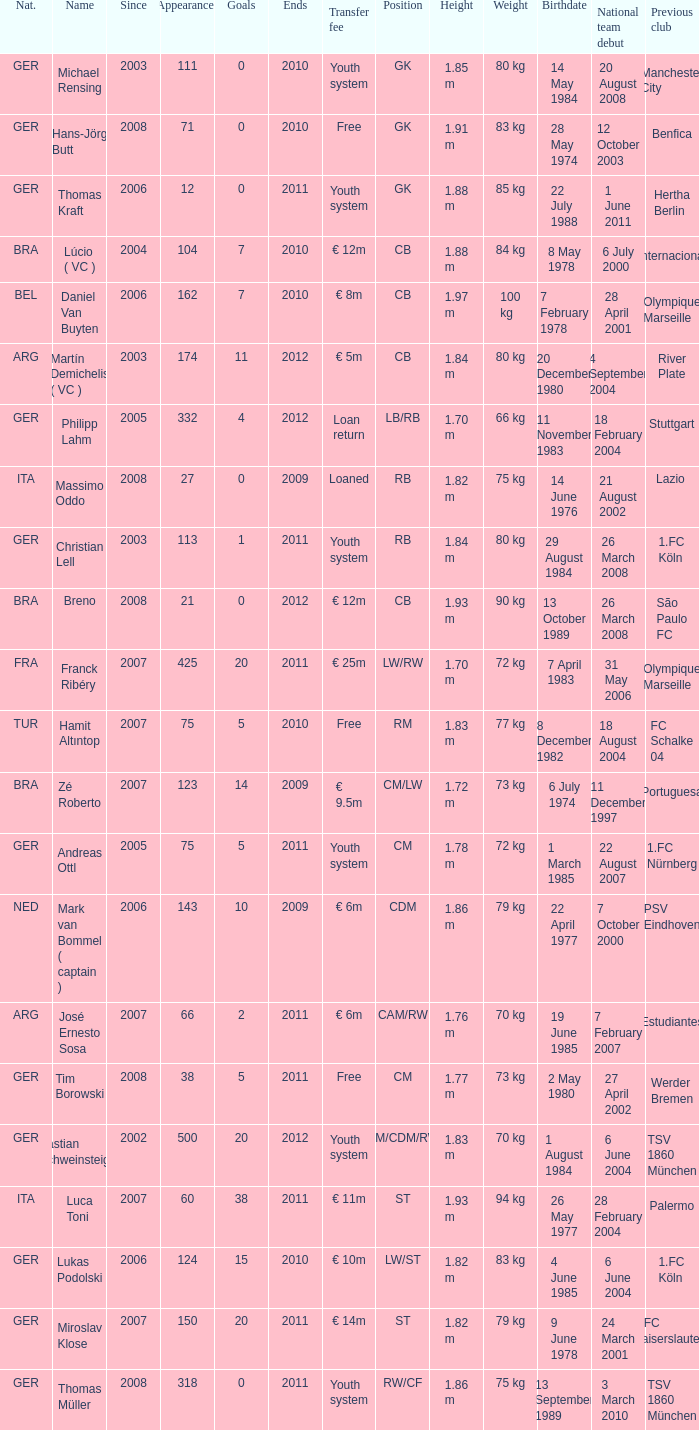What is the total number of ends after 2006 with a nationality of ita and 0 goals? 0.0. Give me the full table as a dictionary. {'header': ['Nat.', 'Name', 'Since', 'Appearances', 'Goals', 'Ends', 'Transfer fee', 'Position', 'Height', 'Weight', 'Birthdate', 'National team debut', 'Previous club '], 'rows': [['GER', 'Michael Rensing', '2003', '111', '0', '2010', 'Youth system', 'GK', '1.85 m', '80 kg', '14 May 1984', '20 August 2008', 'Manchester City '], ['GER', 'Hans-Jörg Butt', '2008', '71', '0', '2010', 'Free', 'GK', '1.91 m', '83 kg', '28 May 1974', '12 October 2003', 'Benfica '], ['GER', 'Thomas Kraft', '2006', '12', '0', '2011', 'Youth system', 'GK', '1.88 m', '85 kg', '22 July 1988', '1 June 2011', 'Hertha Berlin '], ['BRA', 'Lúcio ( VC )', '2004', '104', '7', '2010', '€ 12m', 'CB', '1.88 m', '84 kg', '8 May 1978', '6 July 2000', 'Internacional '], ['BEL', 'Daniel Van Buyten', '2006', '162', '7', '2010', '€ 8m', 'CB', '1.97 m', '100 kg', '7 February 1978', '28 April 2001', 'Olympique Marseille '], ['ARG', 'Martín Demichelis ( VC )', '2003', '174', '11', '2012', '€ 5m', 'CB', '1.84 m', '80 kg', '20 December 1980', '4 September 2004', 'River Plate'], ['GER', 'Philipp Lahm', '2005', '332', '4', '2012', 'Loan return', 'LB/RB', '1.70 m', '66 kg', '11 November 1983', '18 February 2004', 'Stuttgart '], ['ITA', 'Massimo Oddo', '2008', '27', '0', '2009', 'Loaned', 'RB', '1.82 m', '75 kg', '14 June 1976', '21 August 2002', 'Lazio '], ['GER', 'Christian Lell', '2003', '113', '1', '2011', 'Youth system', 'RB', '1.84 m', '80 kg', '29 August 1984', '26 March 2008', '1.FC Köln '], ['BRA', 'Breno', '2008', '21', '0', '2012', '€ 12m', 'CB', '1.93 m', '90 kg', '13 October 1989', '26 March 2008', 'São Paulo FC '], ['FRA', 'Franck Ribéry', '2007', '425', '20', '2011', '€ 25m', 'LW/RW', '1.70 m', '72 kg', '7 April 1983', '31 May 2006', 'Olympique Marseille '], ['TUR', 'Hamit Altıntop', '2007', '75', '5', '2010', 'Free', 'RM', '1.83 m', '77 kg', '8 December 1982', '18 August 2004', 'FC Schalke 04 '], ['BRA', 'Zé Roberto', '2007', '123', '14', '2009', '€ 9.5m', 'CM/LW', '1.72 m', '73 kg', '6 July 1974', '11 December 1997', 'Portuguesa '], ['GER', 'Andreas Ottl', '2005', '75', '5', '2011', 'Youth system', 'CM', '1.78 m', '72 kg', '1 March 1985', '22 August 2007', '1.FC Nürnberg '], ['NED', 'Mark van Bommel ( captain )', '2006', '143', '10', '2009', '€ 6m', 'CDM', '1.86 m', '79 kg', '22 April 1977', '7 October 2000', 'PSV Eindhoven '], ['ARG', 'José Ernesto Sosa', '2007', '66', '2', '2011', '€ 6m', 'CAM/RW', '1.76 m', '70 kg', '19 June 1985', '7 February 2007', 'Estudiantes '], ['GER', 'Tim Borowski', '2008', '38', '5', '2011', 'Free', 'CM', '1.77 m', '73 kg', '2 May 1980', '27 April 2002', 'Werder Bremen '], ['GER', 'Bastian Schweinsteiger', '2002', '500', '20', '2012', 'Youth system', 'CM/CDM/RW', '1.83 m', '70 kg', '1 August 1984', '6 June 2004', 'TSV 1860 München '], ['ITA', 'Luca Toni', '2007', '60', '38', '2011', '€ 11m', 'ST', '1.93 m', '94 kg', '26 May 1977', '28 February 2004', 'Palermo '], ['GER', 'Lukas Podolski', '2006', '124', '15', '2010', '€ 10m', 'LW/ST', '1.82 m', '83 kg', '4 June 1985', '6 June 2004', '1.FC Köln '], ['GER', 'Miroslav Klose', '2007', '150', '20', '2011', '€ 14m', 'ST', '1.82 m', '79 kg', '9 June 1978', '24 March 2001', '1.FC Kaiserslautern '], ['GER', 'Thomas Müller', '2008', '318', '0', '2011', 'Youth system', 'RW/CF', '1.86 m', '75 kg', '13 September 1989', '3 March 2010', 'TSV 1860 München']]} 